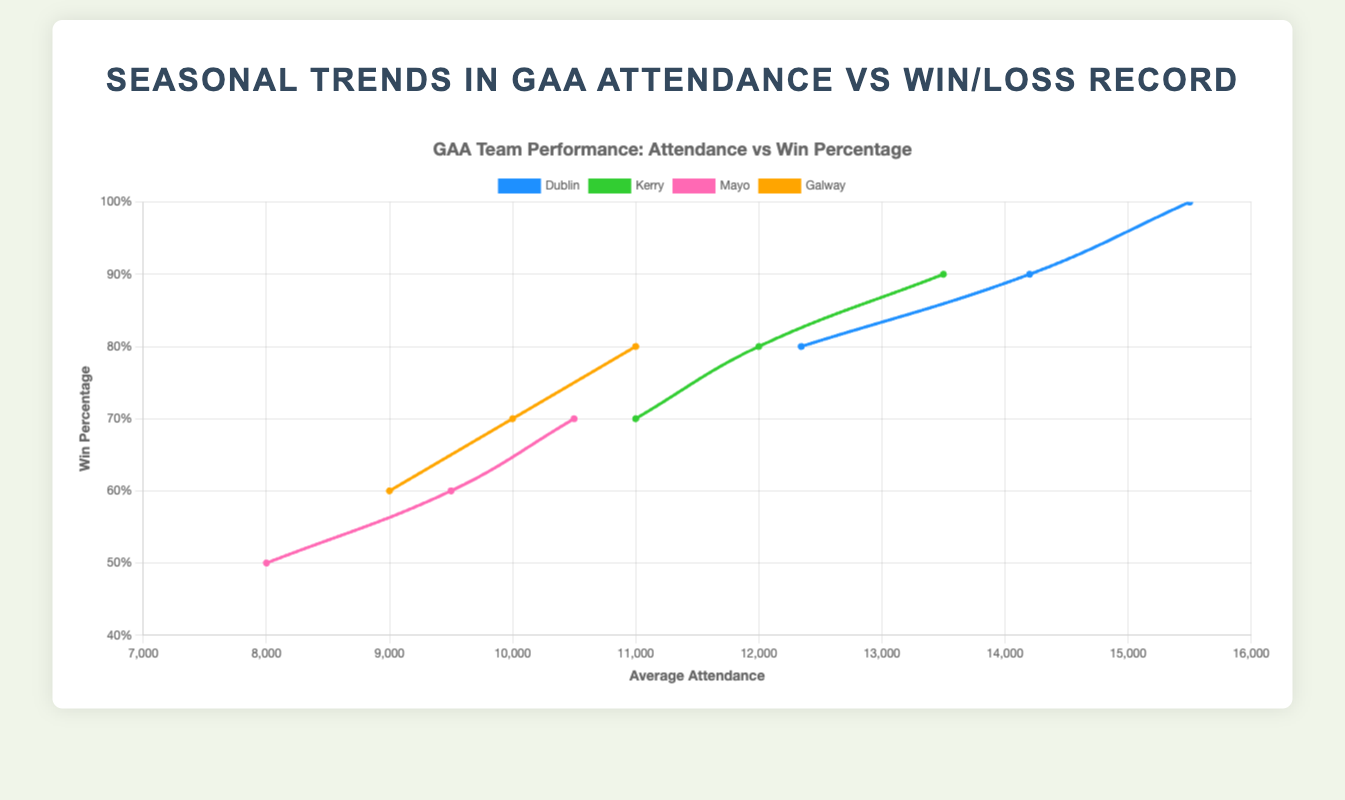Which team had the highest average attendance in 2023 Fall? By looking at the data points on the x-axis corresponding to '2023 Fall' season, we identify the highest value as 15500 for Dublin.
Answer: Dublin Which team showed the greatest increase in attendance from 2023 Spring to 2023 Fall? Calculate the difference in attendance for each team between '2023 Spring' and '2023 Fall'. Dublin: 15500 - 12345 = 3155, Kerry: 13500 - 11000 = 2500, Mayo: 10500 - 8000 = 2500, Galway: 11000 - 9000 = 2000. Dublin had the highest increase.
Answer: Dublin Which season saw Kerry's highest win percentage? For Kerry, visually compare the heights of the y-coordinate points. The highest point on the win percentage scale is during '2023 Fall', which is approximately 90%.
Answer: 2023 Fall Compare the average attendance of Dublin in 2023 Fall and Mayo in 2023 Spring. Which is higher and by how much? Dublin in '2023 Fall' has an attendance of 15500, and Mayo in '2023 Spring' has 8000. The difference is 15500 - 8000 = 7500.
Answer: Dublin by 7500 Which team had the lowest win percentage in 2023 Spring? By looking at the win percentages on the y-axis for '2023 Spring', Mayo had the lowest win percentage at 50%.
Answer: Mayo What can you infer about Dublin’s win percentage trend across the 2023 seasons? Observe the y-axis values for Dublin across the seasons. The win percentage increases from around 80% in Spring, to 90% in Summer, and to 100% in Fall.
Answer: It increases What is the average win percentage for Kerry across all 2023 seasons? Add the win percentages for Kerry (Spring: 70%, Summer: 80%, Fall: 90%) and divide by 3. (70 + 80 + 90) / 3 = 240 / 3 = 80%.
Answer: 80% Which season saw the lowest audience attendance for Galway? Look at the x-axis points for Galway; '2023 Spring' is the lowest with 9000.
Answer: 2023 Spring Does a higher win percentage correlate with higher attendance for Dublin? Compare Dublin’s win percentages and attendance across seasons: Spring (80%, 12345), Summer (90%, 14200), Fall (100%, 15500). Higher win percentages correspond with higher attendance.
Answer: Yes 